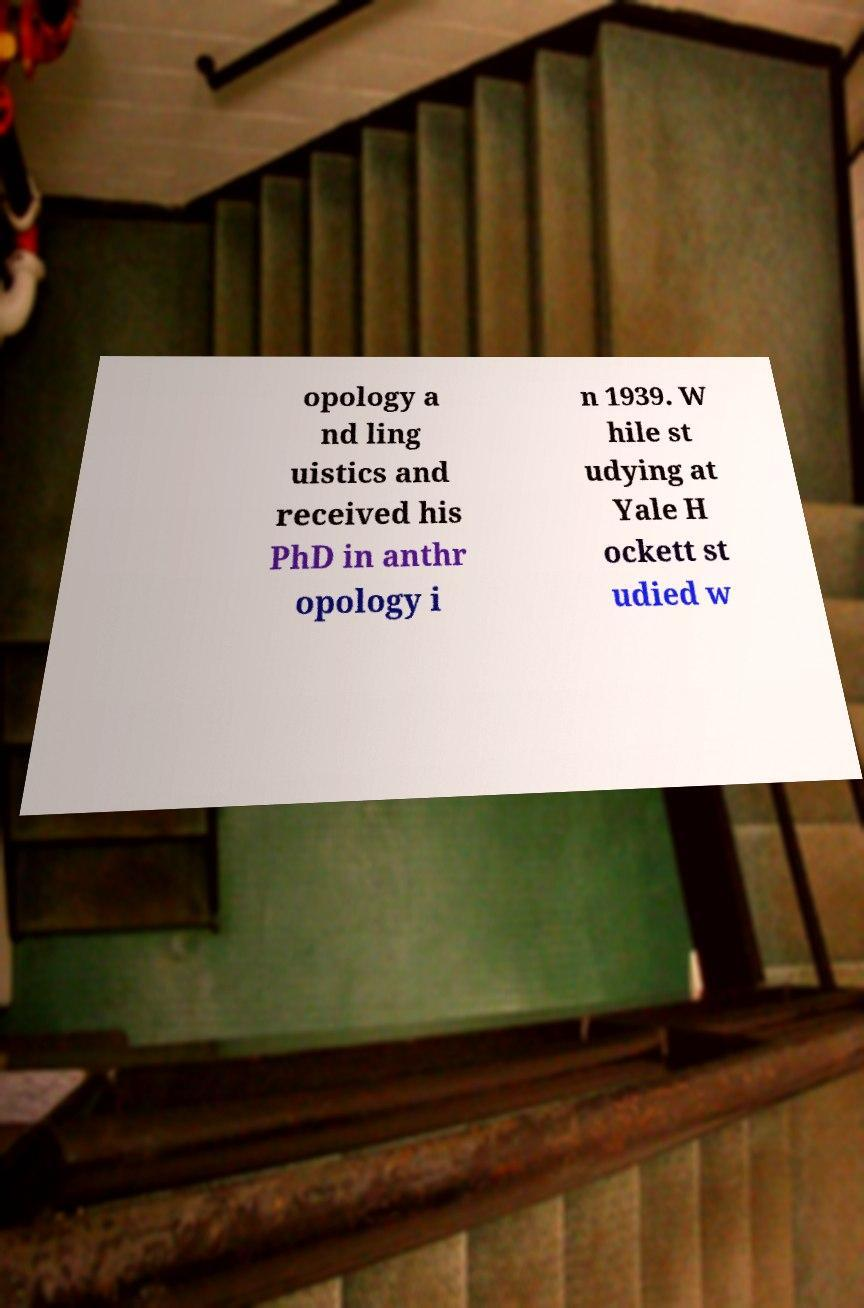Please read and relay the text visible in this image. What does it say? opology a nd ling uistics and received his PhD in anthr opology i n 1939. W hile st udying at Yale H ockett st udied w 